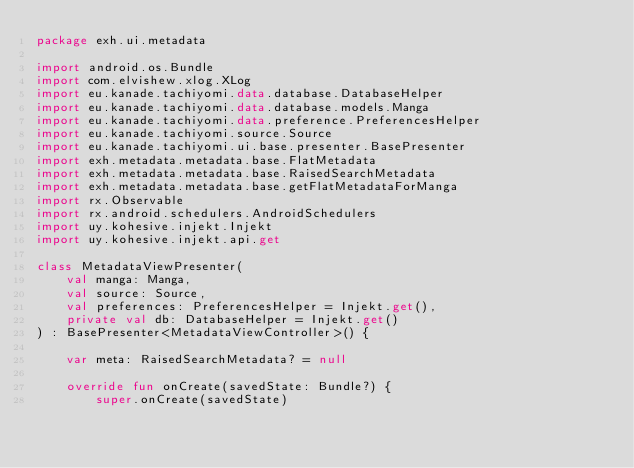Convert code to text. <code><loc_0><loc_0><loc_500><loc_500><_Kotlin_>package exh.ui.metadata

import android.os.Bundle
import com.elvishew.xlog.XLog
import eu.kanade.tachiyomi.data.database.DatabaseHelper
import eu.kanade.tachiyomi.data.database.models.Manga
import eu.kanade.tachiyomi.data.preference.PreferencesHelper
import eu.kanade.tachiyomi.source.Source
import eu.kanade.tachiyomi.ui.base.presenter.BasePresenter
import exh.metadata.metadata.base.FlatMetadata
import exh.metadata.metadata.base.RaisedSearchMetadata
import exh.metadata.metadata.base.getFlatMetadataForManga
import rx.Observable
import rx.android.schedulers.AndroidSchedulers
import uy.kohesive.injekt.Injekt
import uy.kohesive.injekt.api.get

class MetadataViewPresenter(
    val manga: Manga,
    val source: Source,
    val preferences: PreferencesHelper = Injekt.get(),
    private val db: DatabaseHelper = Injekt.get()
) : BasePresenter<MetadataViewController>() {

    var meta: RaisedSearchMetadata? = null

    override fun onCreate(savedState: Bundle?) {
        super.onCreate(savedState)
</code> 